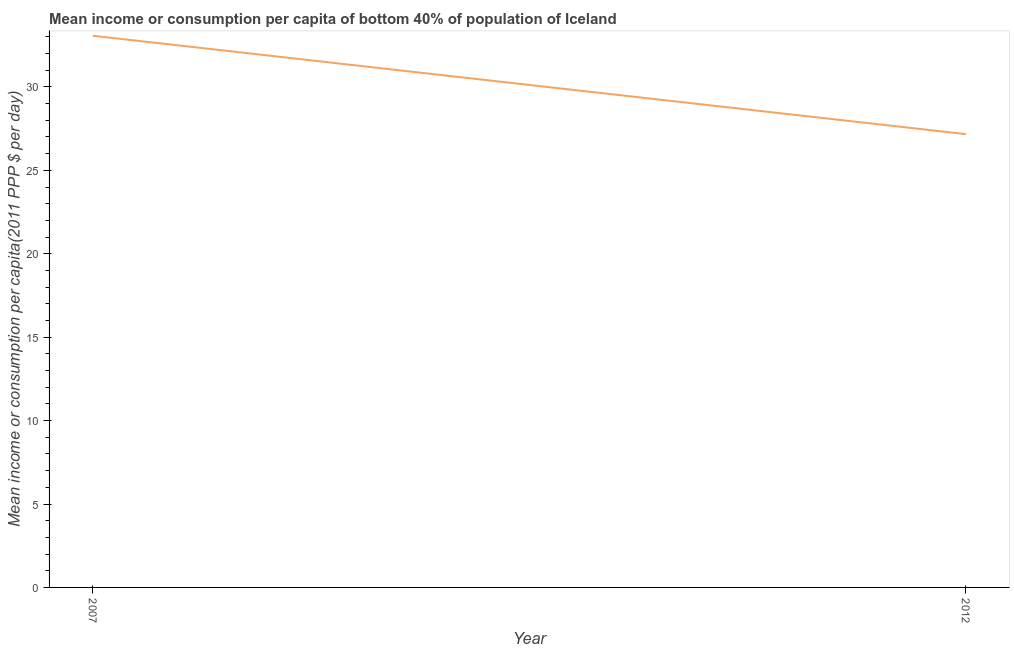What is the mean income or consumption in 2012?
Ensure brevity in your answer.  27.17. Across all years, what is the maximum mean income or consumption?
Give a very brief answer. 33.07. Across all years, what is the minimum mean income or consumption?
Offer a very short reply. 27.17. In which year was the mean income or consumption minimum?
Ensure brevity in your answer.  2012. What is the sum of the mean income or consumption?
Keep it short and to the point. 60.24. What is the difference between the mean income or consumption in 2007 and 2012?
Your answer should be very brief. 5.9. What is the average mean income or consumption per year?
Provide a succinct answer. 30.12. What is the median mean income or consumption?
Provide a short and direct response. 30.12. In how many years, is the mean income or consumption greater than 3 $?
Your answer should be compact. 2. Do a majority of the years between 2012 and 2007 (inclusive) have mean income or consumption greater than 19 $?
Offer a terse response. No. What is the ratio of the mean income or consumption in 2007 to that in 2012?
Keep it short and to the point. 1.22. In how many years, is the mean income or consumption greater than the average mean income or consumption taken over all years?
Give a very brief answer. 1. How many lines are there?
Keep it short and to the point. 1. Does the graph contain any zero values?
Your answer should be very brief. No. What is the title of the graph?
Make the answer very short. Mean income or consumption per capita of bottom 40% of population of Iceland. What is the label or title of the X-axis?
Your response must be concise. Year. What is the label or title of the Y-axis?
Give a very brief answer. Mean income or consumption per capita(2011 PPP $ per day). What is the Mean income or consumption per capita(2011 PPP $ per day) in 2007?
Ensure brevity in your answer.  33.07. What is the Mean income or consumption per capita(2011 PPP $ per day) in 2012?
Your answer should be compact. 27.17. What is the difference between the Mean income or consumption per capita(2011 PPP $ per day) in 2007 and 2012?
Make the answer very short. 5.9. What is the ratio of the Mean income or consumption per capita(2011 PPP $ per day) in 2007 to that in 2012?
Your answer should be compact. 1.22. 